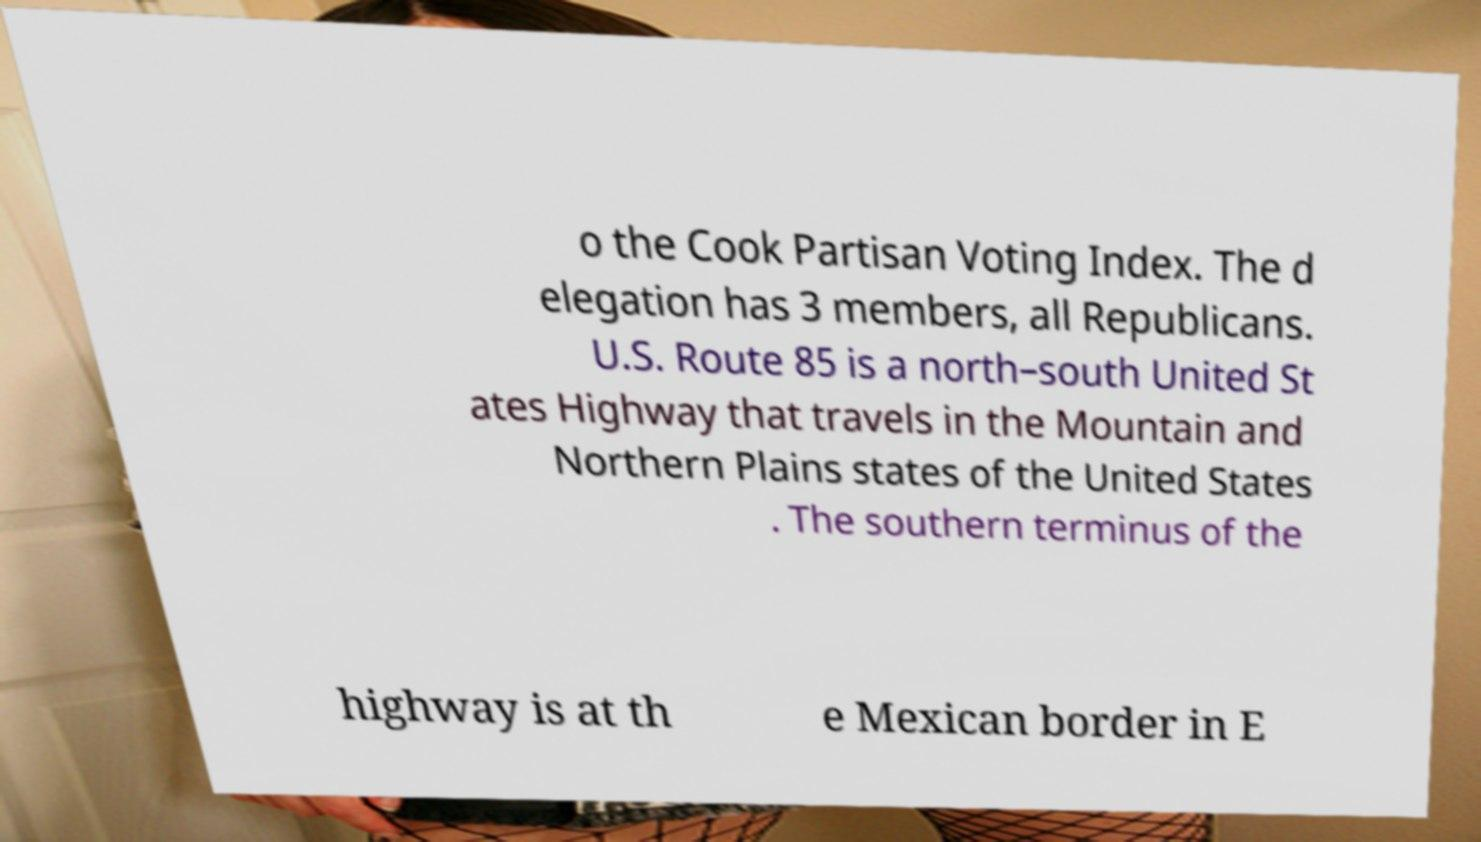Could you extract and type out the text from this image? o the Cook Partisan Voting Index. The d elegation has 3 members, all Republicans. U.S. Route 85 is a north–south United St ates Highway that travels in the Mountain and Northern Plains states of the United States . The southern terminus of the highway is at th e Mexican border in E 